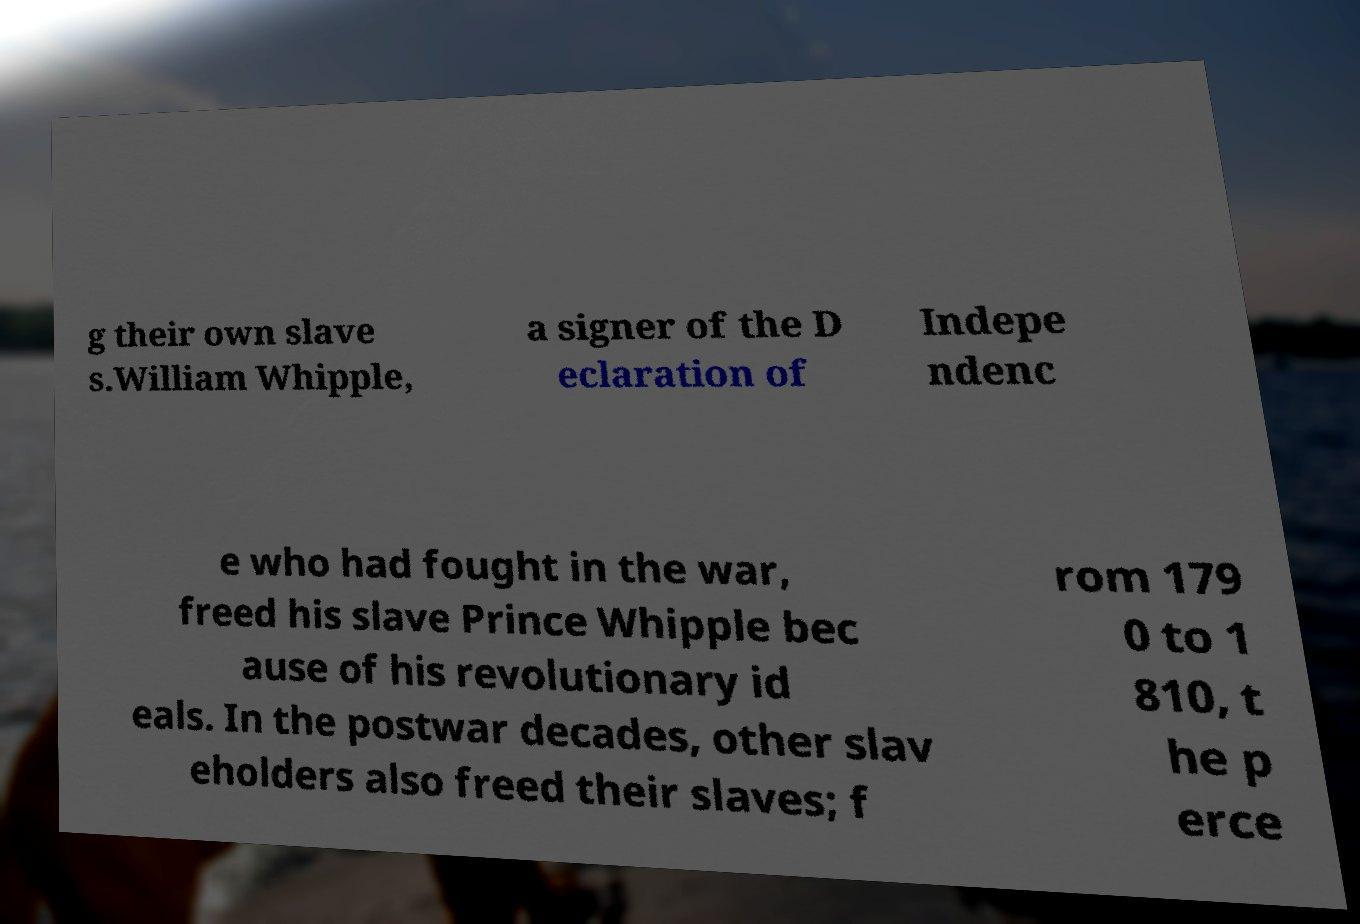There's text embedded in this image that I need extracted. Can you transcribe it verbatim? g their own slave s.William Whipple, a signer of the D eclaration of Indepe ndenc e who had fought in the war, freed his slave Prince Whipple bec ause of his revolutionary id eals. In the postwar decades, other slav eholders also freed their slaves; f rom 179 0 to 1 810, t he p erce 